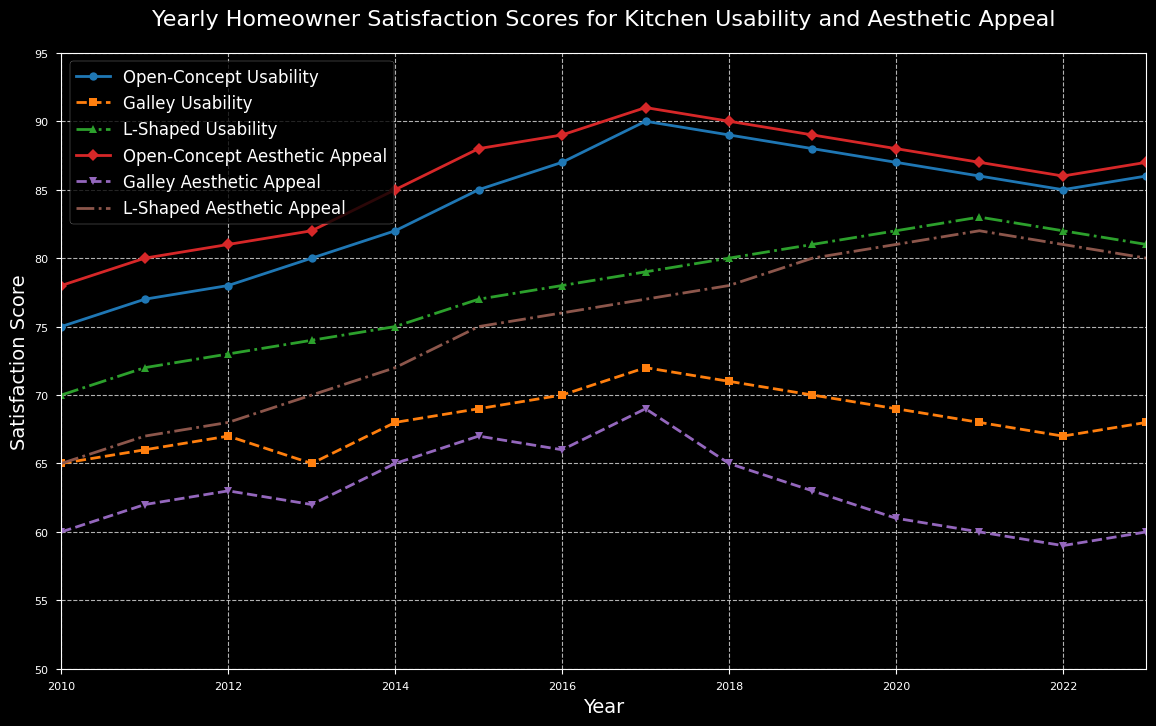Which year did Galley kitchen usability peak? To identify the peak year for Galley Usability, look for the highest point in the line representing Galley Usability. The peak is at 2017 with a score of 72.
Answer: 2017 Compare the usability score of Open-Concept and L-Shaped kitchens in 2019. Which one is higher? Refer to the points on the lines for Open-Concept Usability and L-Shaped Usability at 2019. Open-Concept Usability has a score of 88, while L-Shaped Usability has 81. Thus, Open-Concept is higher.
Answer: Open-Concept What is the average aesthetic appeal score of Galley kitchens from 2010 to 2023? Summing up the Galley Aesthetic Appeal scores for all the years: 60 + 62 + 63 + 62 + 65 + 67 + 66 + 69 + 65 + 63 + 61 + 60 + 59 + 60 = 922. There are 14 years, so 922 / 14 ≈ 65.86.
Answer: 65.86 By how much did Open-Concept usability change from 2010 to 2017? Subtract the 2010 score from the 2017 score. The 2010 score is 75, and the 2017 score is 90. So, 90 - 75 = 15.
Answer: 15 During which year did L-Shaped Aesthetic appeal have the maximum increase from the previous year? Examine the differences between consecutive years for L-Shaped Aesthetic Appeal to find the largest increase. The maximum increase is from 2012 (68) to 2013 (70), which is 2.
Answer: 2013 Which kitchen layout consistently had the highest aesthetic appeal scores throughout the years? Look at the Aesthetic Appeal lines for all three kitchen layouts, and see which one stays highest above the others across all years. Open-Concept consistently had the highest aesthetic appeal scores.
Answer: Open-Concept How do the usability scores of Galley and L-Shaped kitchens in 2023 compare? On the 2023 points of the respective graphs, Galley Usability is at 68, while L-Shaped Usability is at 81. Therefore, L-Shaped scores higher.
Answer: L-Shaped What is the total change in usability for L-Shaped kitchens from 2010 to 2023? Calculate the difference between the 2023 and 2010 scores for L-Shaped Usability. The 2010 score is 70, and the 2023 score is 81, so 81 - 70 = 11.
Answer: 11 In which year did the aesthetic appeal of Galley kitchens first reach or exceed 65? Check the Galley Aesthetic Appeal line graph and identify the first year it is 65 or more. This first occurs in 2014.
Answer: 2014 